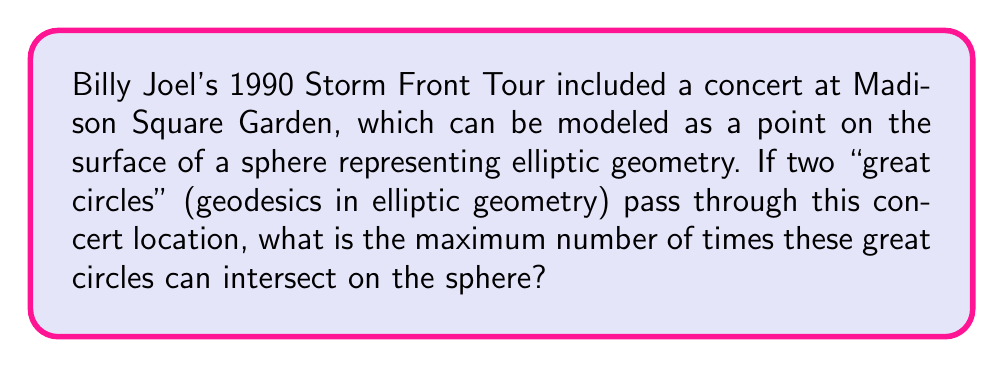Show me your answer to this math problem. Let's approach this step-by-step:

1) In elliptic geometry, the surface of a sphere is used as a model. Points on the sphere represent points in the geometry.

2) Great circles on a sphere are the equivalent of "straight lines" in elliptic geometry. They are formed by the intersection of the sphere with a plane passing through the center of the sphere.

3) The parallel postulate in Euclidean geometry states that through a point not on a given line, there is exactly one line parallel to the given line. However, in elliptic geometry, this postulate does not hold.

4) In elliptic geometry, any two great circles will always intersect at exactly two antipodal points.

5) This is because:
   a) Great circles are formed by planes passing through the center of the sphere.
   b) Two distinct planes always intersect in a line.
   c) This line of intersection will pierce the sphere at two points on opposite sides.

6) These two intersection points are independent of the specific point (in this case, the concert location) through which the great circles pass.

7) Therefore, regardless of where Billy Joel's concert at Madison Square Garden is located on our spherical model, two great circles passing through this point will always intersect at exactly two points.

This demonstrates a fundamental difference between Euclidean and elliptic geometry, showcasing how the parallel postulate fails in elliptic geometry.
Answer: 2 